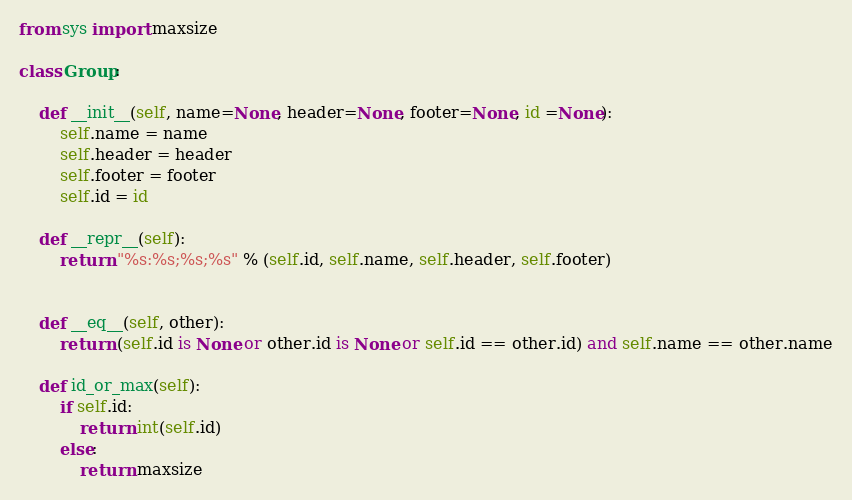Convert code to text. <code><loc_0><loc_0><loc_500><loc_500><_Python_>from sys import maxsize

class Group:

    def __init__(self, name=None, header=None, footer=None, id =None):
        self.name = name
        self.header = header
        self.footer = footer
        self.id = id

    def __repr__(self):
        return "%s:%s;%s;%s" % (self.id, self.name, self.header, self.footer)


    def __eq__(self, other):
        return (self.id is None or other.id is None or self.id == other.id) and self.name == other.name

    def id_or_max(self):
        if self.id:
            return int(self.id)
        else:
            return maxsize</code> 